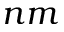Convert formula to latex. <formula><loc_0><loc_0><loc_500><loc_500>n m</formula> 